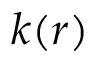Convert formula to latex. <formula><loc_0><loc_0><loc_500><loc_500>k ( r )</formula> 